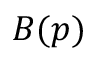Convert formula to latex. <formula><loc_0><loc_0><loc_500><loc_500>B ( p )</formula> 